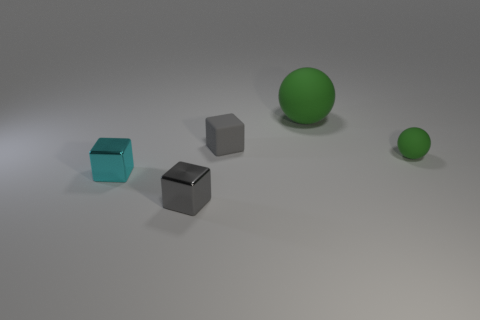Are the green ball in front of the gray rubber cube and the big sphere made of the same material?
Your answer should be compact. Yes. What is the shape of the small rubber thing that is on the left side of the tiny matte object that is to the right of the tiny gray object behind the tiny green matte object?
Make the answer very short. Cube. Are there an equal number of tiny cyan shiny blocks right of the tiny cyan shiny cube and small cyan metallic cubes behind the tiny green thing?
Ensure brevity in your answer.  Yes. The rubber ball that is the same size as the rubber cube is what color?
Provide a succinct answer. Green. What number of big things are either rubber spheres or red rubber cylinders?
Offer a terse response. 1. There is a tiny object that is both in front of the rubber cube and behind the cyan metallic cube; what material is it?
Provide a short and direct response. Rubber. There is a gray thing behind the cyan object; does it have the same shape as the small rubber thing on the right side of the big sphere?
Your answer should be compact. No. What shape is the metallic object that is the same color as the rubber block?
Provide a succinct answer. Cube. What number of things are either tiny things that are to the left of the gray rubber thing or small green rubber things?
Make the answer very short. 3. Do the cyan metallic thing and the gray metallic thing have the same size?
Your response must be concise. Yes. 